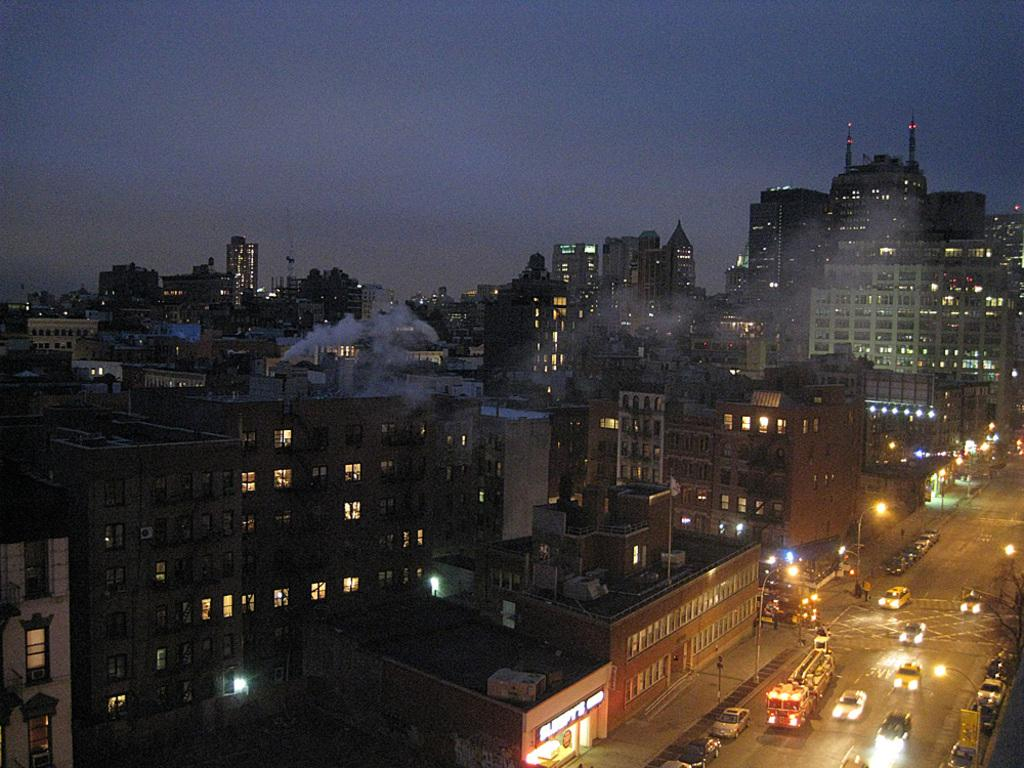What is happening on the road in the image? There are vehicles moving on the road in the image. What can be seen on the path in the image? There are poles with lights on the path in the image. What is located on the left side of the vehicles in the image? There are buildings on the left side of the vehicles in the image. What is visible on the left side of the vehicles in the image? There is smoke visible on the left side of the vehicles in the image. What is visible in the background of the image? The sky is visible in the image. Where is the desk located in the image? There is no desk present in the image. What type of development is taking place on the left side of the vehicles in the image? There is no development taking place in the image; it only shows vehicles, buildings, and smoke. What is the doll doing in the image? There is no doll present in the image. 